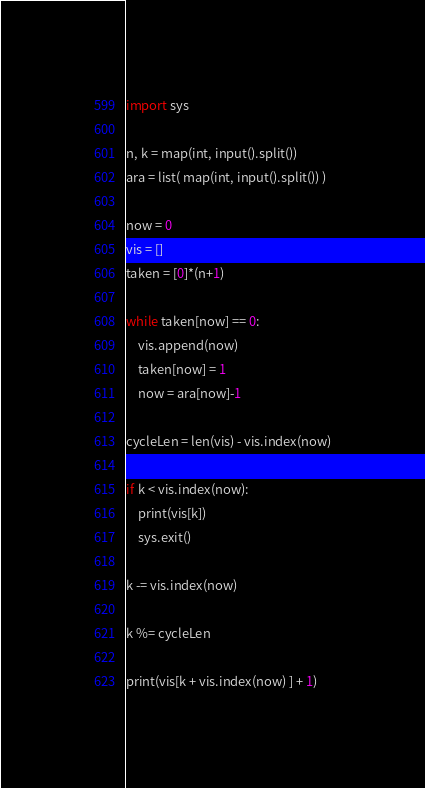Convert code to text. <code><loc_0><loc_0><loc_500><loc_500><_Python_>import sys

n, k = map(int, input().split())
ara = list( map(int, input().split()) )

now = 0
vis = []
taken = [0]*(n+1)

while taken[now] == 0:
	vis.append(now)
	taken[now] = 1
	now = ara[now]-1

cycleLen = len(vis) - vis.index(now)

if k < vis.index(now):
	print(vis[k])
	sys.exit()

k -= vis.index(now)

k %= cycleLen

print(vis[k + vis.index(now) ] + 1)



</code> 